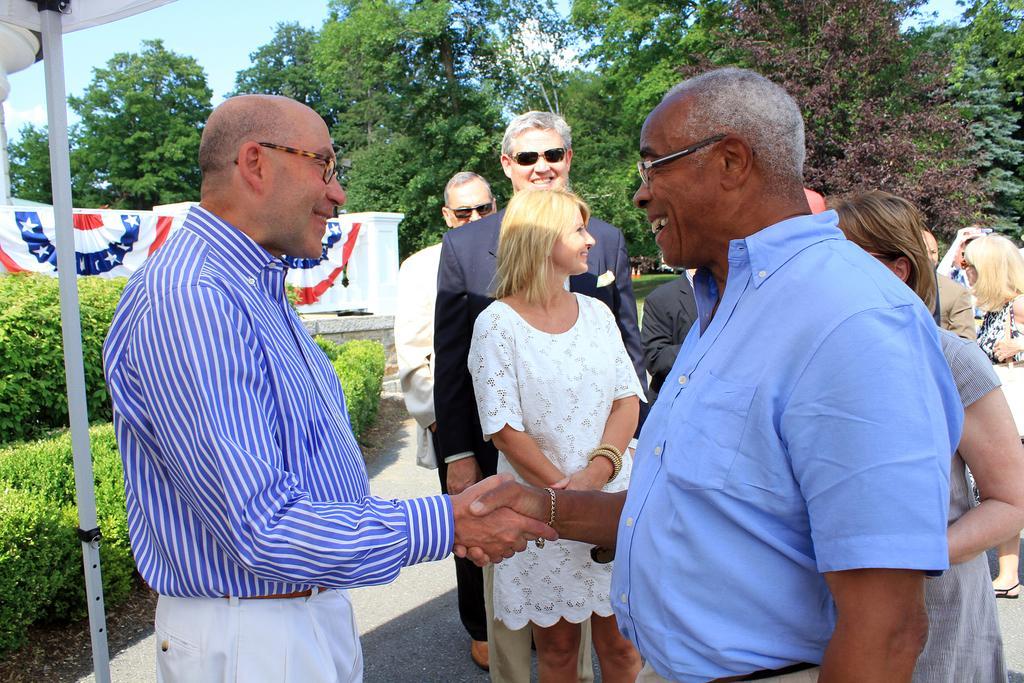Could you give a brief overview of what you see in this image? In this image there are a group of people standing, in the foreground there are two persons who are shaking hands with each other and they are smiling. And in the background there are some trees, on the left side there is a pole and there is a cloth and a wall. At the bottom there is a walkway. 